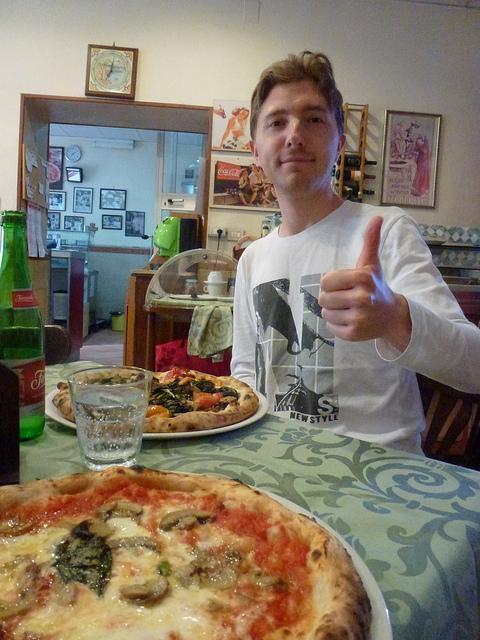Why is the man giving a thumbs up to the viewer?
Indicate the correct response by choosing from the four available options to answer the question.
Options: Showing approval, showing off, rating movies, playing prank. Showing approval. 